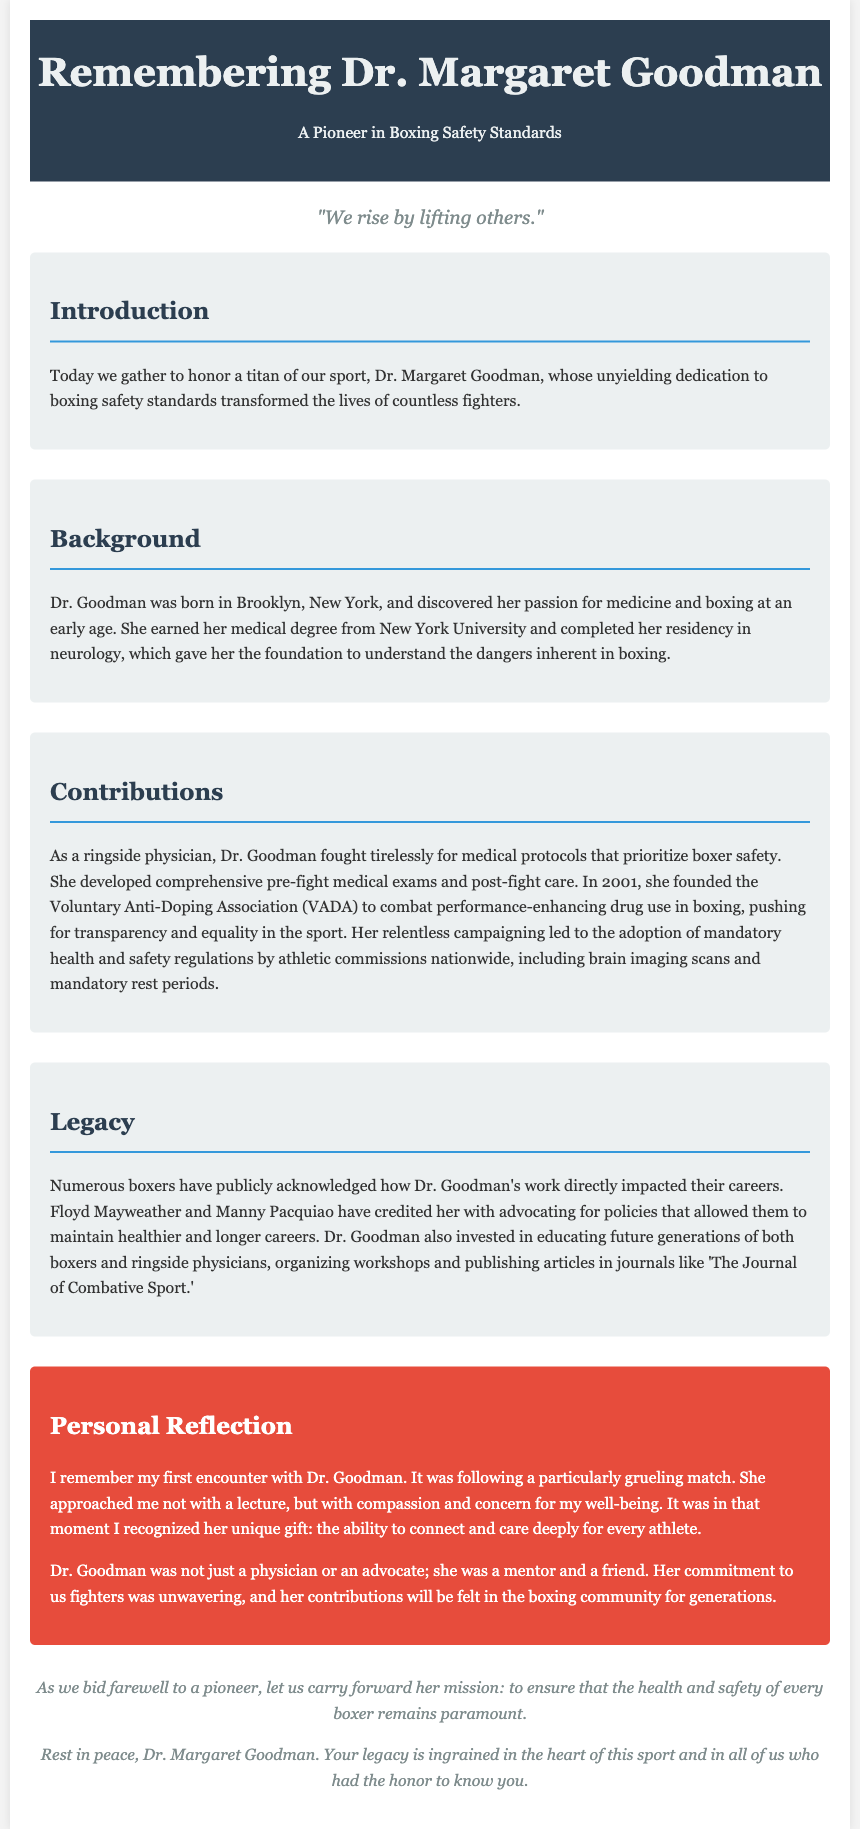What is the name of the pioneer being honored? The document discusses Dr. Margaret Goodman, highlighting her contributions to boxing safety standards.
Answer: Dr. Margaret Goodman Where was Dr. Goodman born? The document states that she was born in Brooklyn, New York.
Answer: Brooklyn, New York In what year did Dr. Goodman found the Voluntary Anti-Doping Association (VADA)? The document specifies that she founded VADA in 2001.
Answer: 2001 What notable health measure did Dr. Goodman advocate for? The document mentions her advocacy for mandatory health and safety regulations, including brain imaging scans.
Answer: Brain imaging scans Which two famous boxers acknowledged Dr. Goodman's impact on their careers? The document cites Floyd Mayweather and Manny Pacquiao as boxers who recognized her contributions.
Answer: Floyd Mayweather and Manny Pacquiao What is described as Dr. Goodman's unique gift? The personal reflection section describes her unique gift as the ability to connect and care deeply for every athlete.
Answer: The ability to connect and care What role did Dr. Goodman play in the boxing community? The document highlights that she was a physician, advocate, mentor, and friend to boxers.
Answer: Physician, advocate, mentor, friend What is the closing message of the eulogy? The document's closing emphasizes the mission to ensure the health and safety of every boxer.
Answer: To ensure the health and safety of every boxer What is the primary theme of this eulogy? The document centers around the dedication and legacy of Dr. Goodman in boxing safety standards.
Answer: Dedication to boxing safety standards 